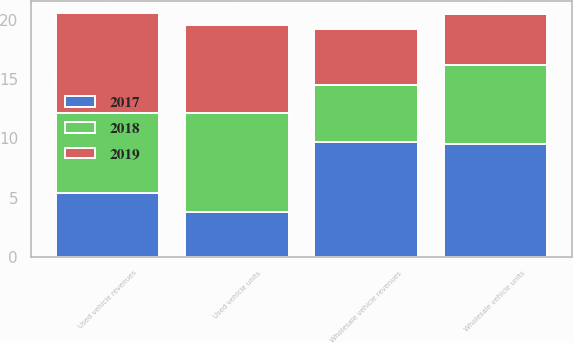Convert chart. <chart><loc_0><loc_0><loc_500><loc_500><stacked_bar_chart><ecel><fcel>Used vehicle units<fcel>Used vehicle revenues<fcel>Wholesale vehicle units<fcel>Wholesale vehicle revenues<nl><fcel>2017<fcel>3.8<fcel>5.4<fcel>9.5<fcel>9.7<nl><fcel>2019<fcel>7.5<fcel>8.5<fcel>4.3<fcel>4.7<nl><fcel>2018<fcel>8.3<fcel>6.7<fcel>6.7<fcel>4.8<nl></chart> 